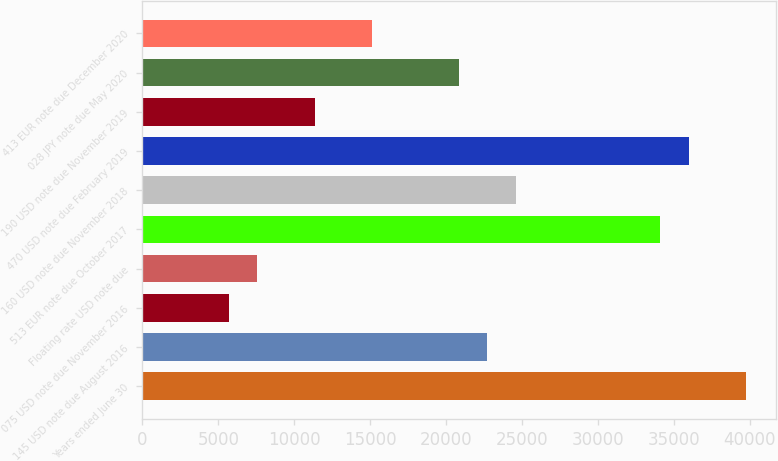<chart> <loc_0><loc_0><loc_500><loc_500><bar_chart><fcel>Years ended June 30<fcel>145 USD note due August 2016<fcel>075 USD note due November 2016<fcel>Floating rate USD note due<fcel>513 EUR note due October 2017<fcel>160 USD note due November 2018<fcel>470 USD note due February 2019<fcel>190 USD note due November 2019<fcel>028 JPY note due May 2020<fcel>413 EUR note due December 2020<nl><fcel>39781.1<fcel>22733.4<fcel>5685.67<fcel>7579.86<fcel>34098.5<fcel>24627.6<fcel>35992.7<fcel>11368.2<fcel>20839.2<fcel>15156.6<nl></chart> 